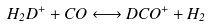<formula> <loc_0><loc_0><loc_500><loc_500>H _ { 2 } D ^ { + } + C O \longleftrightarrow D C O ^ { + } + H _ { 2 }</formula> 